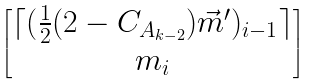<formula> <loc_0><loc_0><loc_500><loc_500>\begin{bmatrix} \lceil ( \frac { 1 } { 2 } ( 2 - C _ { A _ { k - 2 } } ) \vec { m } ^ { \prime } ) _ { i - 1 } \rceil \\ m _ { i } \end{bmatrix}</formula> 